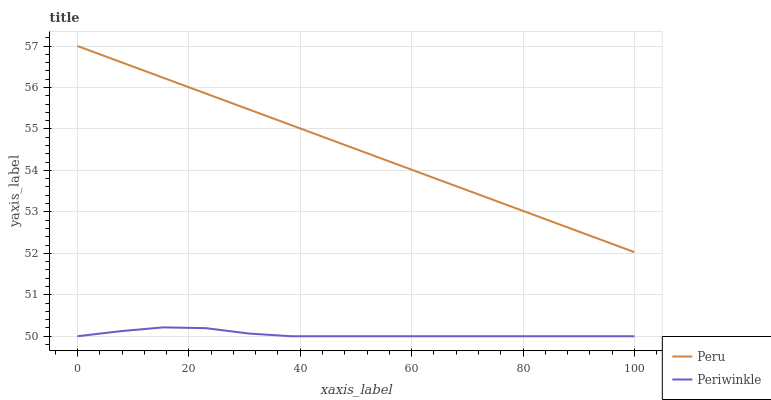Does Periwinkle have the minimum area under the curve?
Answer yes or no. Yes. Does Peru have the maximum area under the curve?
Answer yes or no. Yes. Does Peru have the minimum area under the curve?
Answer yes or no. No. Is Peru the smoothest?
Answer yes or no. Yes. Is Periwinkle the roughest?
Answer yes or no. Yes. Is Peru the roughest?
Answer yes or no. No. Does Peru have the lowest value?
Answer yes or no. No. Does Peru have the highest value?
Answer yes or no. Yes. Is Periwinkle less than Peru?
Answer yes or no. Yes. Is Peru greater than Periwinkle?
Answer yes or no. Yes. Does Periwinkle intersect Peru?
Answer yes or no. No. 